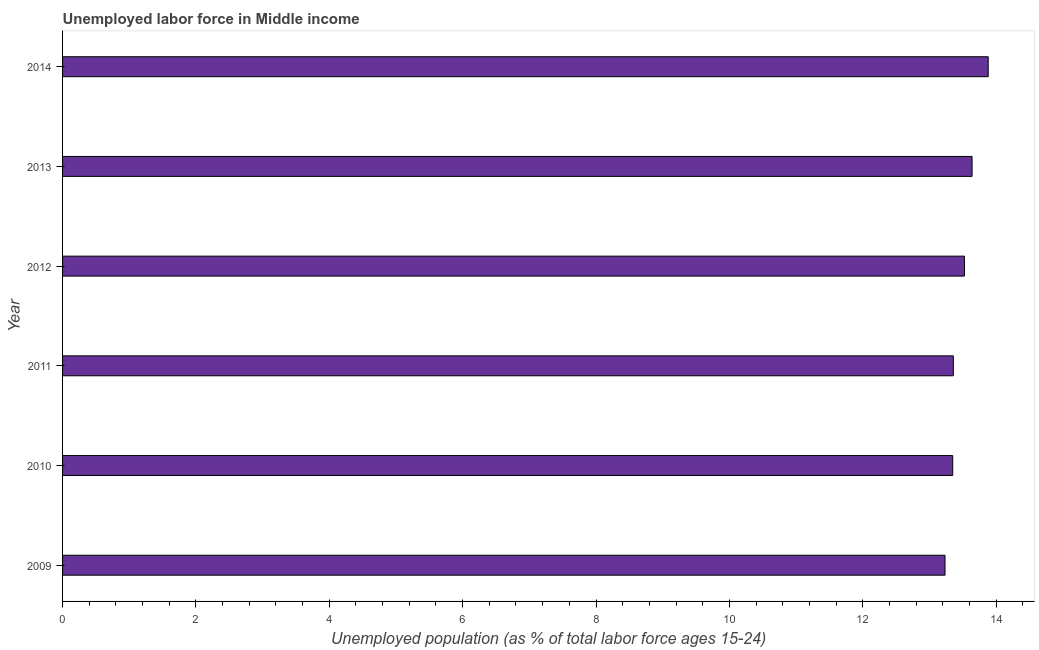Does the graph contain any zero values?
Provide a short and direct response. No. Does the graph contain grids?
Give a very brief answer. No. What is the title of the graph?
Ensure brevity in your answer.  Unemployed labor force in Middle income. What is the label or title of the X-axis?
Give a very brief answer. Unemployed population (as % of total labor force ages 15-24). What is the label or title of the Y-axis?
Ensure brevity in your answer.  Year. What is the total unemployed youth population in 2014?
Give a very brief answer. 13.88. Across all years, what is the maximum total unemployed youth population?
Offer a very short reply. 13.88. Across all years, what is the minimum total unemployed youth population?
Keep it short and to the point. 13.23. In which year was the total unemployed youth population maximum?
Make the answer very short. 2014. In which year was the total unemployed youth population minimum?
Keep it short and to the point. 2009. What is the sum of the total unemployed youth population?
Provide a short and direct response. 80.99. What is the difference between the total unemployed youth population in 2011 and 2013?
Offer a terse response. -0.28. What is the average total unemployed youth population per year?
Provide a short and direct response. 13.5. What is the median total unemployed youth population?
Make the answer very short. 13.44. In how many years, is the total unemployed youth population greater than 8.4 %?
Provide a short and direct response. 6. What is the ratio of the total unemployed youth population in 2009 to that in 2014?
Make the answer very short. 0.95. Is the difference between the total unemployed youth population in 2009 and 2014 greater than the difference between any two years?
Your answer should be compact. Yes. What is the difference between the highest and the second highest total unemployed youth population?
Make the answer very short. 0.24. What is the difference between the highest and the lowest total unemployed youth population?
Offer a terse response. 0.65. In how many years, is the total unemployed youth population greater than the average total unemployed youth population taken over all years?
Provide a succinct answer. 3. How many bars are there?
Your answer should be compact. 6. What is the difference between two consecutive major ticks on the X-axis?
Your answer should be compact. 2. What is the Unemployed population (as % of total labor force ages 15-24) of 2009?
Your response must be concise. 13.23. What is the Unemployed population (as % of total labor force ages 15-24) of 2010?
Provide a short and direct response. 13.35. What is the Unemployed population (as % of total labor force ages 15-24) in 2011?
Your response must be concise. 13.36. What is the Unemployed population (as % of total labor force ages 15-24) of 2012?
Give a very brief answer. 13.53. What is the Unemployed population (as % of total labor force ages 15-24) in 2013?
Make the answer very short. 13.64. What is the Unemployed population (as % of total labor force ages 15-24) of 2014?
Ensure brevity in your answer.  13.88. What is the difference between the Unemployed population (as % of total labor force ages 15-24) in 2009 and 2010?
Offer a terse response. -0.12. What is the difference between the Unemployed population (as % of total labor force ages 15-24) in 2009 and 2011?
Offer a terse response. -0.12. What is the difference between the Unemployed population (as % of total labor force ages 15-24) in 2009 and 2012?
Keep it short and to the point. -0.29. What is the difference between the Unemployed population (as % of total labor force ages 15-24) in 2009 and 2013?
Your answer should be compact. -0.41. What is the difference between the Unemployed population (as % of total labor force ages 15-24) in 2009 and 2014?
Offer a terse response. -0.65. What is the difference between the Unemployed population (as % of total labor force ages 15-24) in 2010 and 2011?
Provide a short and direct response. -0.01. What is the difference between the Unemployed population (as % of total labor force ages 15-24) in 2010 and 2012?
Keep it short and to the point. -0.18. What is the difference between the Unemployed population (as % of total labor force ages 15-24) in 2010 and 2013?
Keep it short and to the point. -0.29. What is the difference between the Unemployed population (as % of total labor force ages 15-24) in 2010 and 2014?
Keep it short and to the point. -0.53. What is the difference between the Unemployed population (as % of total labor force ages 15-24) in 2011 and 2012?
Give a very brief answer. -0.17. What is the difference between the Unemployed population (as % of total labor force ages 15-24) in 2011 and 2013?
Keep it short and to the point. -0.28. What is the difference between the Unemployed population (as % of total labor force ages 15-24) in 2011 and 2014?
Offer a very short reply. -0.52. What is the difference between the Unemployed population (as % of total labor force ages 15-24) in 2012 and 2013?
Provide a short and direct response. -0.11. What is the difference between the Unemployed population (as % of total labor force ages 15-24) in 2012 and 2014?
Provide a short and direct response. -0.36. What is the difference between the Unemployed population (as % of total labor force ages 15-24) in 2013 and 2014?
Your response must be concise. -0.24. What is the ratio of the Unemployed population (as % of total labor force ages 15-24) in 2009 to that in 2010?
Keep it short and to the point. 0.99. What is the ratio of the Unemployed population (as % of total labor force ages 15-24) in 2009 to that in 2012?
Your answer should be compact. 0.98. What is the ratio of the Unemployed population (as % of total labor force ages 15-24) in 2009 to that in 2014?
Offer a very short reply. 0.95. What is the ratio of the Unemployed population (as % of total labor force ages 15-24) in 2010 to that in 2013?
Your response must be concise. 0.98. What is the ratio of the Unemployed population (as % of total labor force ages 15-24) in 2010 to that in 2014?
Keep it short and to the point. 0.96. What is the ratio of the Unemployed population (as % of total labor force ages 15-24) in 2011 to that in 2012?
Your answer should be very brief. 0.99. What is the ratio of the Unemployed population (as % of total labor force ages 15-24) in 2011 to that in 2014?
Provide a succinct answer. 0.96. What is the ratio of the Unemployed population (as % of total labor force ages 15-24) in 2012 to that in 2013?
Provide a short and direct response. 0.99. What is the ratio of the Unemployed population (as % of total labor force ages 15-24) in 2013 to that in 2014?
Keep it short and to the point. 0.98. 